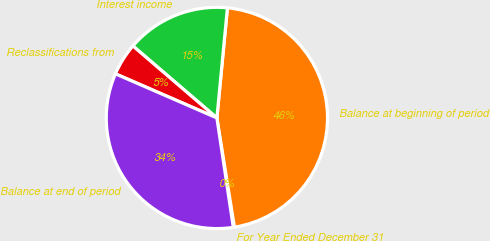Convert chart to OTSL. <chart><loc_0><loc_0><loc_500><loc_500><pie_chart><fcel>For Year Ended December 31<fcel>Balance at beginning of period<fcel>Interest income<fcel>Reclassifications from<fcel>Balance at end of period<nl><fcel>0.17%<fcel>45.94%<fcel>15.24%<fcel>4.75%<fcel>33.9%<nl></chart> 